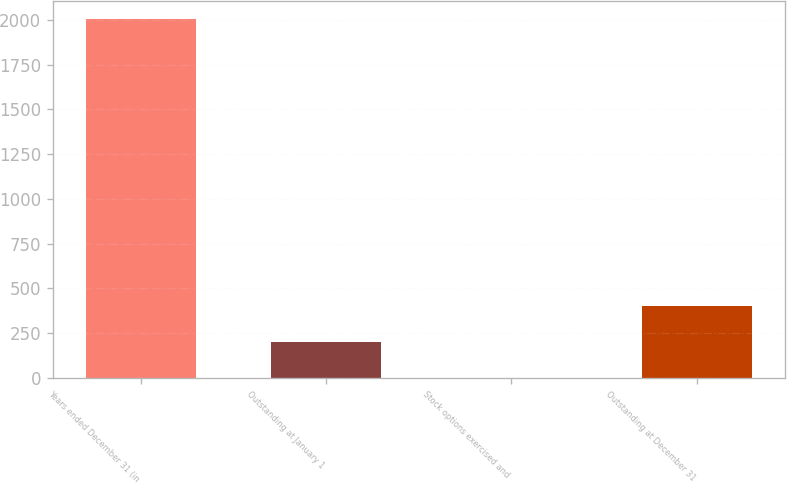Convert chart to OTSL. <chart><loc_0><loc_0><loc_500><loc_500><bar_chart><fcel>Years ended December 31 (in<fcel>Outstanding at January 1<fcel>Stock options exercised and<fcel>Outstanding at December 31<nl><fcel>2005<fcel>201.22<fcel>0.8<fcel>401.64<nl></chart> 